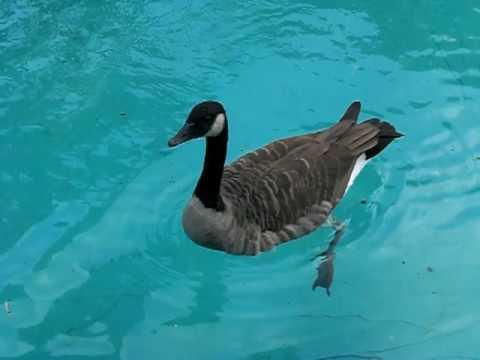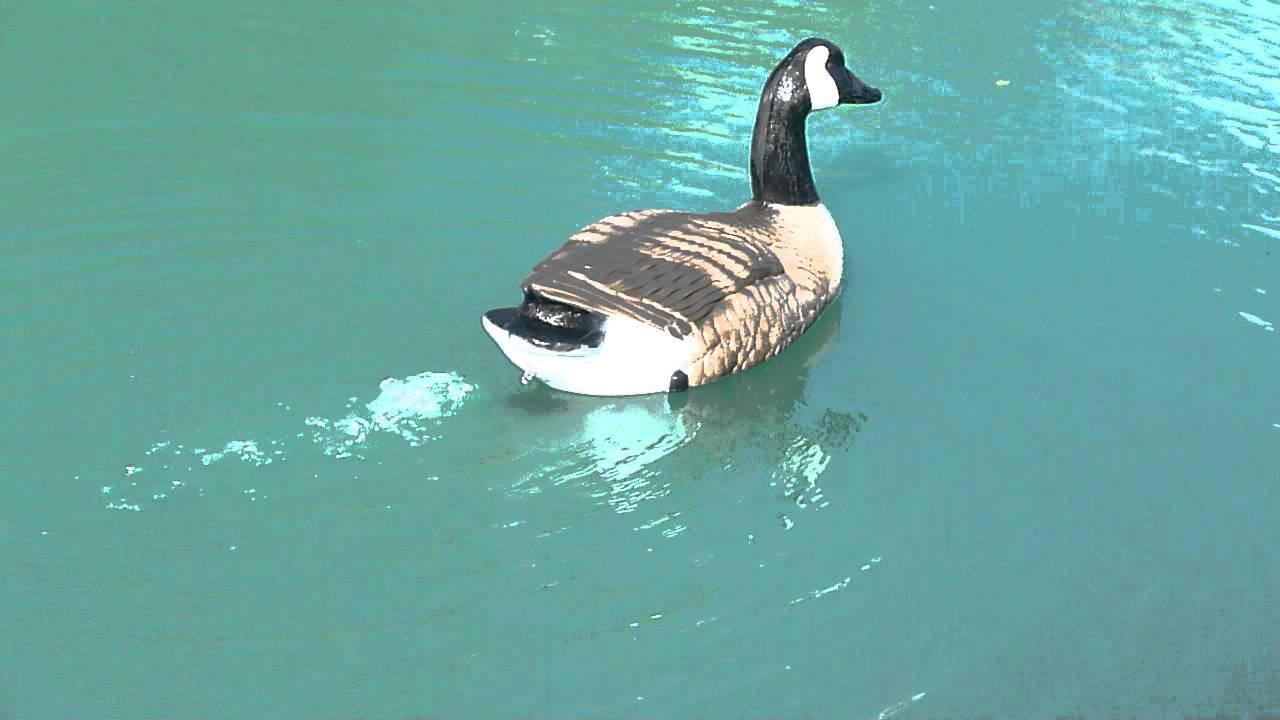The first image is the image on the left, the second image is the image on the right. For the images displayed, is the sentence "Each image shows exactly one bird floating on water, and at least one of the birds is a Canadian goose." factually correct? Answer yes or no. Yes. The first image is the image on the left, the second image is the image on the right. For the images shown, is this caption "The right image contains at least two ducks." true? Answer yes or no. No. 